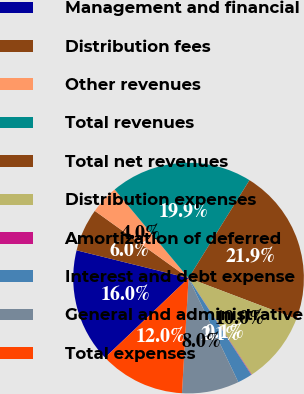<chart> <loc_0><loc_0><loc_500><loc_500><pie_chart><fcel>Management and financial<fcel>Distribution fees<fcel>Other revenues<fcel>Total revenues<fcel>Total net revenues<fcel>Distribution expenses<fcel>Amortization of deferred<fcel>Interest and debt expense<fcel>General and administrative<fcel>Total expenses<nl><fcel>15.98%<fcel>6.03%<fcel>4.04%<fcel>19.92%<fcel>21.91%<fcel>10.0%<fcel>0.07%<fcel>2.06%<fcel>8.01%<fcel>11.98%<nl></chart> 